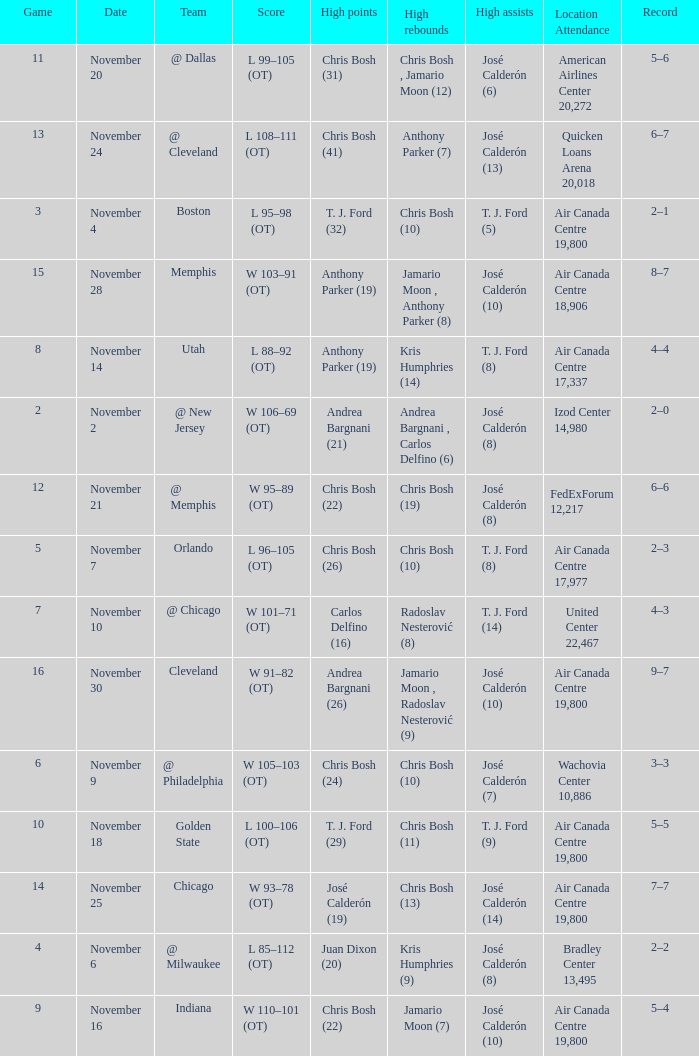What is the score when the team is @ cleveland? L 108–111 (OT). 